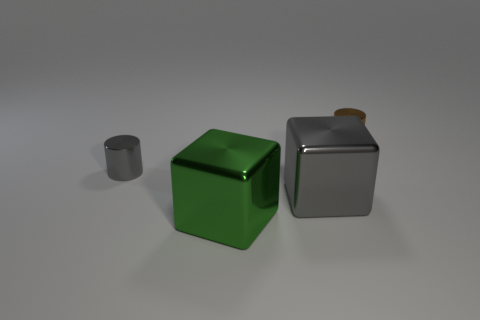There is a gray metallic thing that is the same shape as the green shiny object; what is its size?
Offer a very short reply. Large. Does the small shiny object that is to the left of the brown object have the same shape as the small brown metal object?
Make the answer very short. Yes. The shiny cylinder in front of the brown shiny cylinder is what color?
Your response must be concise. Gray. What number of other objects are the same size as the green metallic block?
Ensure brevity in your answer.  1. Is there any other thing that has the same shape as the small gray thing?
Your response must be concise. Yes. Is the number of metal cylinders left of the gray shiny cylinder the same as the number of big gray shiny objects?
Make the answer very short. No. How many tiny cylinders are the same material as the tiny gray thing?
Give a very brief answer. 1. There is a small object that is made of the same material as the brown cylinder; what is its color?
Your answer should be compact. Gray. Is the large gray object the same shape as the green thing?
Make the answer very short. Yes. Is there a tiny brown metal cylinder in front of the tiny cylinder right of the small metallic thing that is on the left side of the big gray metallic object?
Offer a very short reply. No. 